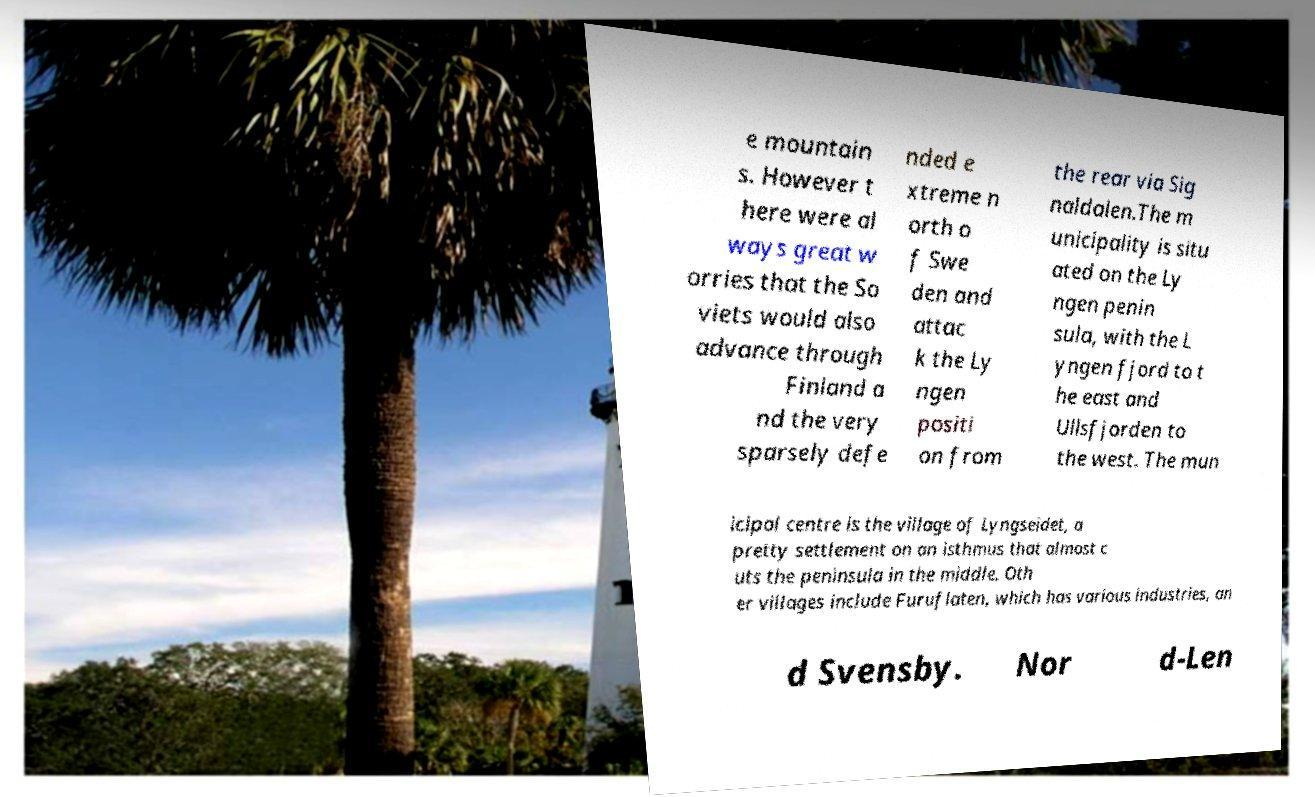What messages or text are displayed in this image? I need them in a readable, typed format. e mountain s. However t here were al ways great w orries that the So viets would also advance through Finland a nd the very sparsely defe nded e xtreme n orth o f Swe den and attac k the Ly ngen positi on from the rear via Sig naldalen.The m unicipality is situ ated on the Ly ngen penin sula, with the L yngen fjord to t he east and Ullsfjorden to the west. The mun icipal centre is the village of Lyngseidet, a pretty settlement on an isthmus that almost c uts the peninsula in the middle. Oth er villages include Furuflaten, which has various industries, an d Svensby. Nor d-Len 